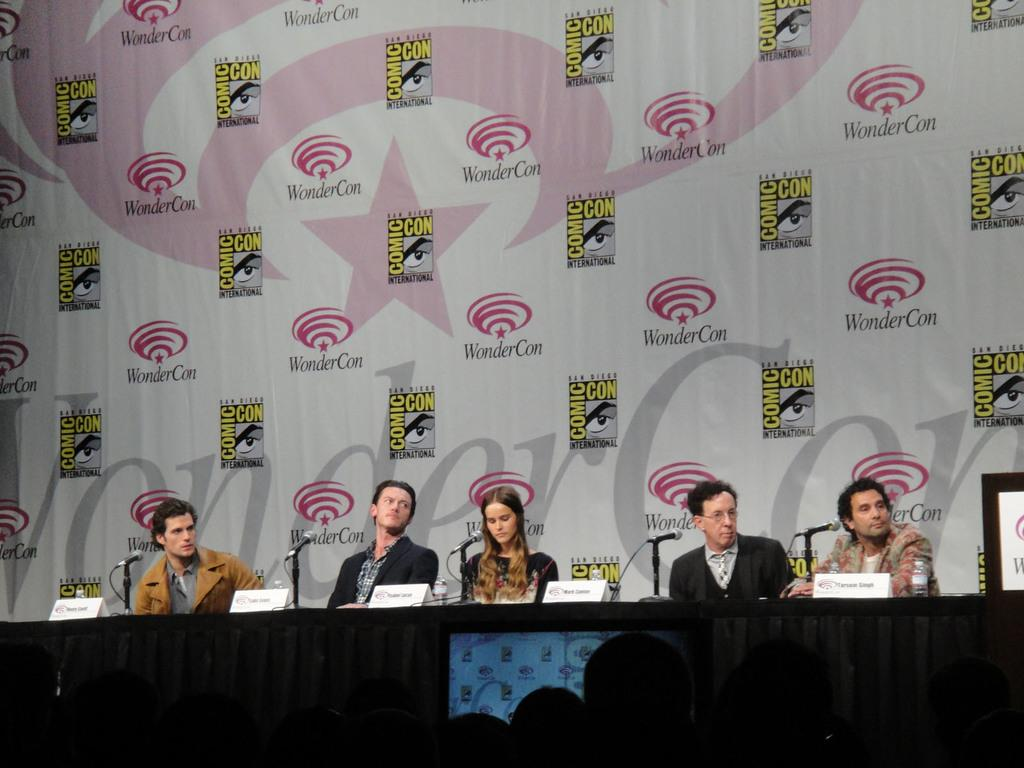What is happening in the foreground of the image? There are people sitting in the foreground of the image. What is on the table in front of the people? There are mice on the table in front of the people. What can be seen on the table besides the mice? There are place cards on the table. What can be seen in the background of the image? There is a poster visible in the background of the image. How many parents are present in the image? There is no mention of parents in the image; it features people sitting and mice on a table. What type of store can be seen in the background of the image? There is no store present in the image; it features a poster in the background. 